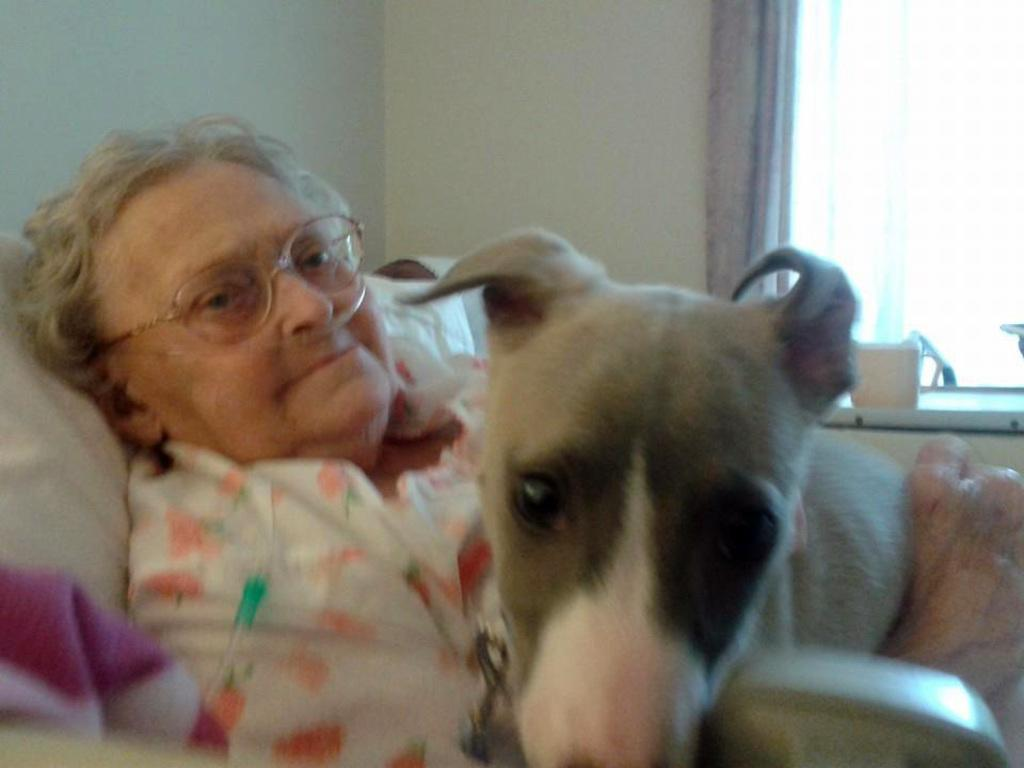Who is the main subject in the image? There is an old woman in the image. What is the old woman doing in the image? The old woman is lying on the bed. What accessory is the old woman wearing in the image? The old woman is wearing spectacles. What is the position of the dog in the image? There is a dog on the old woman. What can be seen in the background of the image? There is a window, a curtain, and a wall in the background of the image. How many dolls are sitting on the window sill in the image? There are no dolls present in the image; it features an old woman lying on the bed with a dog on her. What type of match is being used by the old woman in the image? There is no match present in the image, and the old woman is not using any matches. 